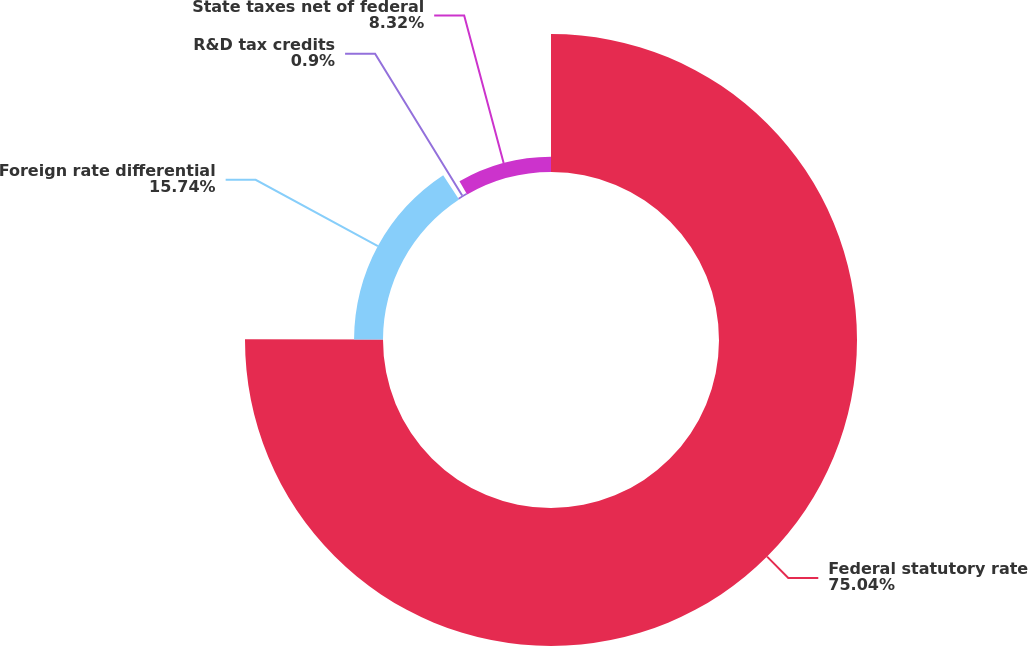<chart> <loc_0><loc_0><loc_500><loc_500><pie_chart><fcel>Federal statutory rate<fcel>Foreign rate differential<fcel>R&D tax credits<fcel>State taxes net of federal<nl><fcel>75.04%<fcel>15.74%<fcel>0.9%<fcel>8.32%<nl></chart> 